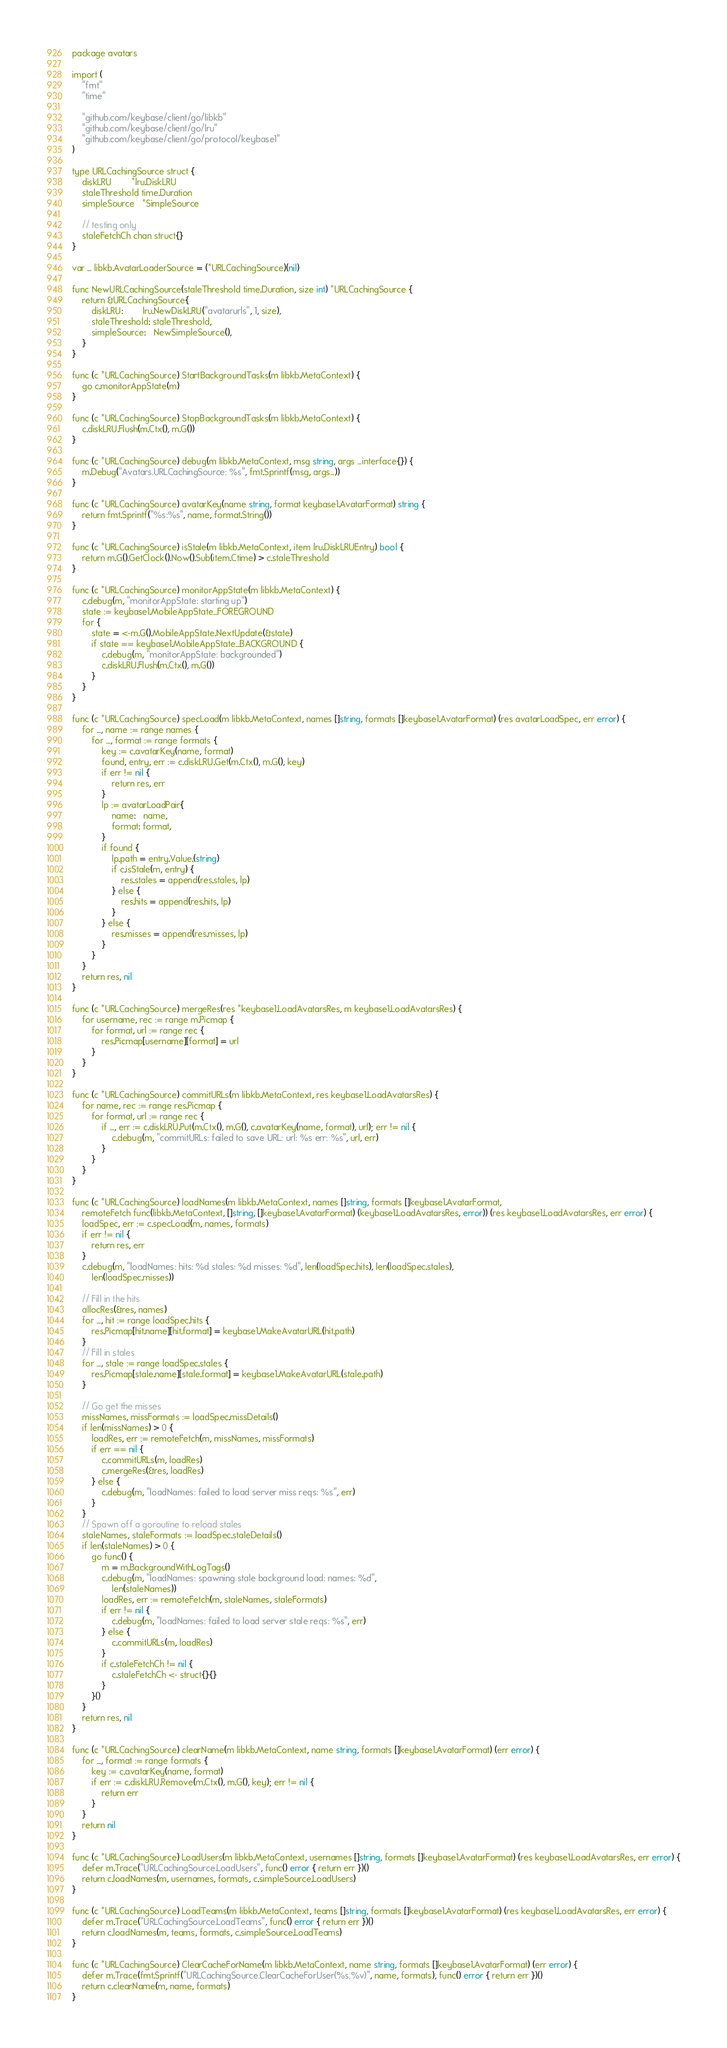Convert code to text. <code><loc_0><loc_0><loc_500><loc_500><_Go_>package avatars

import (
	"fmt"
	"time"

	"github.com/keybase/client/go/libkb"
	"github.com/keybase/client/go/lru"
	"github.com/keybase/client/go/protocol/keybase1"
)

type URLCachingSource struct {
	diskLRU        *lru.DiskLRU
	staleThreshold time.Duration
	simpleSource   *SimpleSource

	// testing only
	staleFetchCh chan struct{}
}

var _ libkb.AvatarLoaderSource = (*URLCachingSource)(nil)

func NewURLCachingSource(staleThreshold time.Duration, size int) *URLCachingSource {
	return &URLCachingSource{
		diskLRU:        lru.NewDiskLRU("avatarurls", 1, size),
		staleThreshold: staleThreshold,
		simpleSource:   NewSimpleSource(),
	}
}

func (c *URLCachingSource) StartBackgroundTasks(m libkb.MetaContext) {
	go c.monitorAppState(m)
}

func (c *URLCachingSource) StopBackgroundTasks(m libkb.MetaContext) {
	c.diskLRU.Flush(m.Ctx(), m.G())
}

func (c *URLCachingSource) debug(m libkb.MetaContext, msg string, args ...interface{}) {
	m.Debug("Avatars.URLCachingSource: %s", fmt.Sprintf(msg, args...))
}

func (c *URLCachingSource) avatarKey(name string, format keybase1.AvatarFormat) string {
	return fmt.Sprintf("%s:%s", name, format.String())
}

func (c *URLCachingSource) isStale(m libkb.MetaContext, item lru.DiskLRUEntry) bool {
	return m.G().GetClock().Now().Sub(item.Ctime) > c.staleThreshold
}

func (c *URLCachingSource) monitorAppState(m libkb.MetaContext) {
	c.debug(m, "monitorAppState: starting up")
	state := keybase1.MobileAppState_FOREGROUND
	for {
		state = <-m.G().MobileAppState.NextUpdate(&state)
		if state == keybase1.MobileAppState_BACKGROUND {
			c.debug(m, "monitorAppState: backgrounded")
			c.diskLRU.Flush(m.Ctx(), m.G())
		}
	}
}

func (c *URLCachingSource) specLoad(m libkb.MetaContext, names []string, formats []keybase1.AvatarFormat) (res avatarLoadSpec, err error) {
	for _, name := range names {
		for _, format := range formats {
			key := c.avatarKey(name, format)
			found, entry, err := c.diskLRU.Get(m.Ctx(), m.G(), key)
			if err != nil {
				return res, err
			}
			lp := avatarLoadPair{
				name:   name,
				format: format,
			}
			if found {
				lp.path = entry.Value.(string)
				if c.isStale(m, entry) {
					res.stales = append(res.stales, lp)
				} else {
					res.hits = append(res.hits, lp)
				}
			} else {
				res.misses = append(res.misses, lp)
			}
		}
	}
	return res, nil
}

func (c *URLCachingSource) mergeRes(res *keybase1.LoadAvatarsRes, m keybase1.LoadAvatarsRes) {
	for username, rec := range m.Picmap {
		for format, url := range rec {
			res.Picmap[username][format] = url
		}
	}
}

func (c *URLCachingSource) commitURLs(m libkb.MetaContext, res keybase1.LoadAvatarsRes) {
	for name, rec := range res.Picmap {
		for format, url := range rec {
			if _, err := c.diskLRU.Put(m.Ctx(), m.G(), c.avatarKey(name, format), url); err != nil {
				c.debug(m, "commitURLs: failed to save URL: url: %s err: %s", url, err)
			}
		}
	}
}

func (c *URLCachingSource) loadNames(m libkb.MetaContext, names []string, formats []keybase1.AvatarFormat,
	remoteFetch func(libkb.MetaContext, []string, []keybase1.AvatarFormat) (keybase1.LoadAvatarsRes, error)) (res keybase1.LoadAvatarsRes, err error) {
	loadSpec, err := c.specLoad(m, names, formats)
	if err != nil {
		return res, err
	}
	c.debug(m, "loadNames: hits: %d stales: %d misses: %d", len(loadSpec.hits), len(loadSpec.stales),
		len(loadSpec.misses))

	// Fill in the hits
	allocRes(&res, names)
	for _, hit := range loadSpec.hits {
		res.Picmap[hit.name][hit.format] = keybase1.MakeAvatarURL(hit.path)
	}
	// Fill in stales
	for _, stale := range loadSpec.stales {
		res.Picmap[stale.name][stale.format] = keybase1.MakeAvatarURL(stale.path)
	}

	// Go get the misses
	missNames, missFormats := loadSpec.missDetails()
	if len(missNames) > 0 {
		loadRes, err := remoteFetch(m, missNames, missFormats)
		if err == nil {
			c.commitURLs(m, loadRes)
			c.mergeRes(&res, loadRes)
		} else {
			c.debug(m, "loadNames: failed to load server miss reqs: %s", err)
		}
	}
	// Spawn off a goroutine to reload stales
	staleNames, staleFormats := loadSpec.staleDetails()
	if len(staleNames) > 0 {
		go func() {
			m = m.BackgroundWithLogTags()
			c.debug(m, "loadNames: spawning stale background load: names: %d",
				len(staleNames))
			loadRes, err := remoteFetch(m, staleNames, staleFormats)
			if err != nil {
				c.debug(m, "loadNames: failed to load server stale reqs: %s", err)
			} else {
				c.commitURLs(m, loadRes)
			}
			if c.staleFetchCh != nil {
				c.staleFetchCh <- struct{}{}
			}
		}()
	}
	return res, nil
}

func (c *URLCachingSource) clearName(m libkb.MetaContext, name string, formats []keybase1.AvatarFormat) (err error) {
	for _, format := range formats {
		key := c.avatarKey(name, format)
		if err := c.diskLRU.Remove(m.Ctx(), m.G(), key); err != nil {
			return err
		}
	}
	return nil
}

func (c *URLCachingSource) LoadUsers(m libkb.MetaContext, usernames []string, formats []keybase1.AvatarFormat) (res keybase1.LoadAvatarsRes, err error) {
	defer m.Trace("URLCachingSource.LoadUsers", func() error { return err })()
	return c.loadNames(m, usernames, formats, c.simpleSource.LoadUsers)
}

func (c *URLCachingSource) LoadTeams(m libkb.MetaContext, teams []string, formats []keybase1.AvatarFormat) (res keybase1.LoadAvatarsRes, err error) {
	defer m.Trace("URLCachingSource.LoadTeams", func() error { return err })()
	return c.loadNames(m, teams, formats, c.simpleSource.LoadTeams)
}

func (c *URLCachingSource) ClearCacheForName(m libkb.MetaContext, name string, formats []keybase1.AvatarFormat) (err error) {
	defer m.Trace(fmt.Sprintf("URLCachingSource.ClearCacheForUser(%s,%v)", name, formats), func() error { return err })()
	return c.clearName(m, name, formats)
}
</code> 